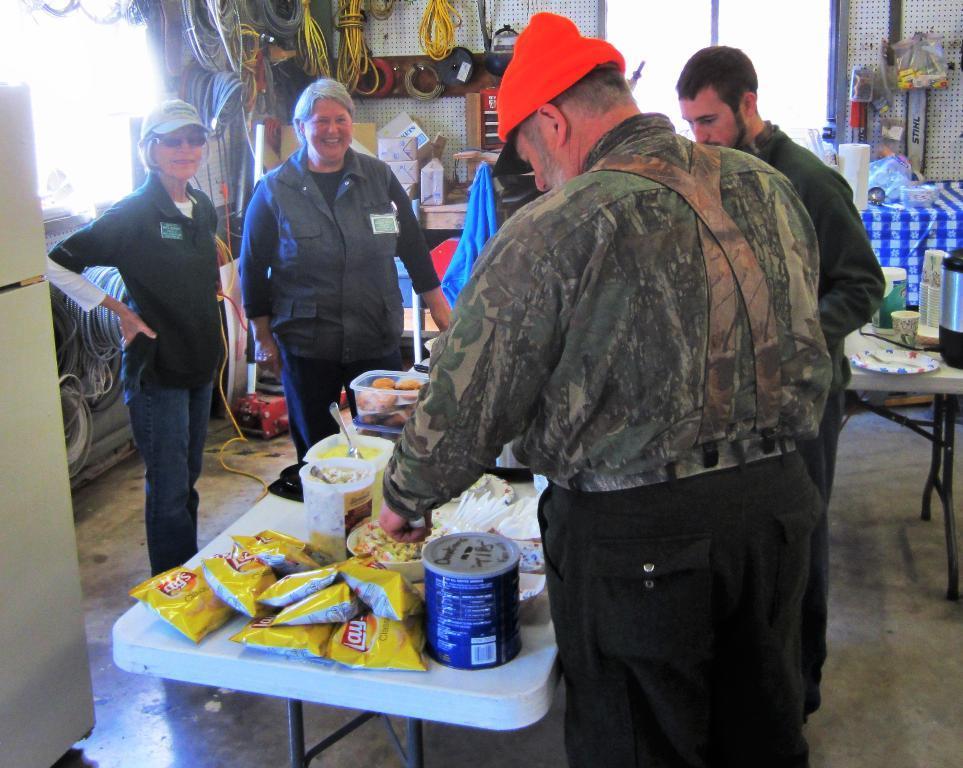How would you summarize this image in a sentence or two? There are four people standing. This is a table with the chip packets, tin, bowls and few other things on it. These are the ropes, which are hanging on the wall. Here is another table, which is covered with the cloth. I can see a flask, paper cups and few other things are placed on the table. On the left side of the image, that looks like a refrigerator. In the background, I think this is a window. 